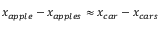Convert formula to latex. <formula><loc_0><loc_0><loc_500><loc_500>x _ { a p p l e } - x _ { a p p l e s } \approx x _ { c a r } - x _ { c a r s }</formula> 